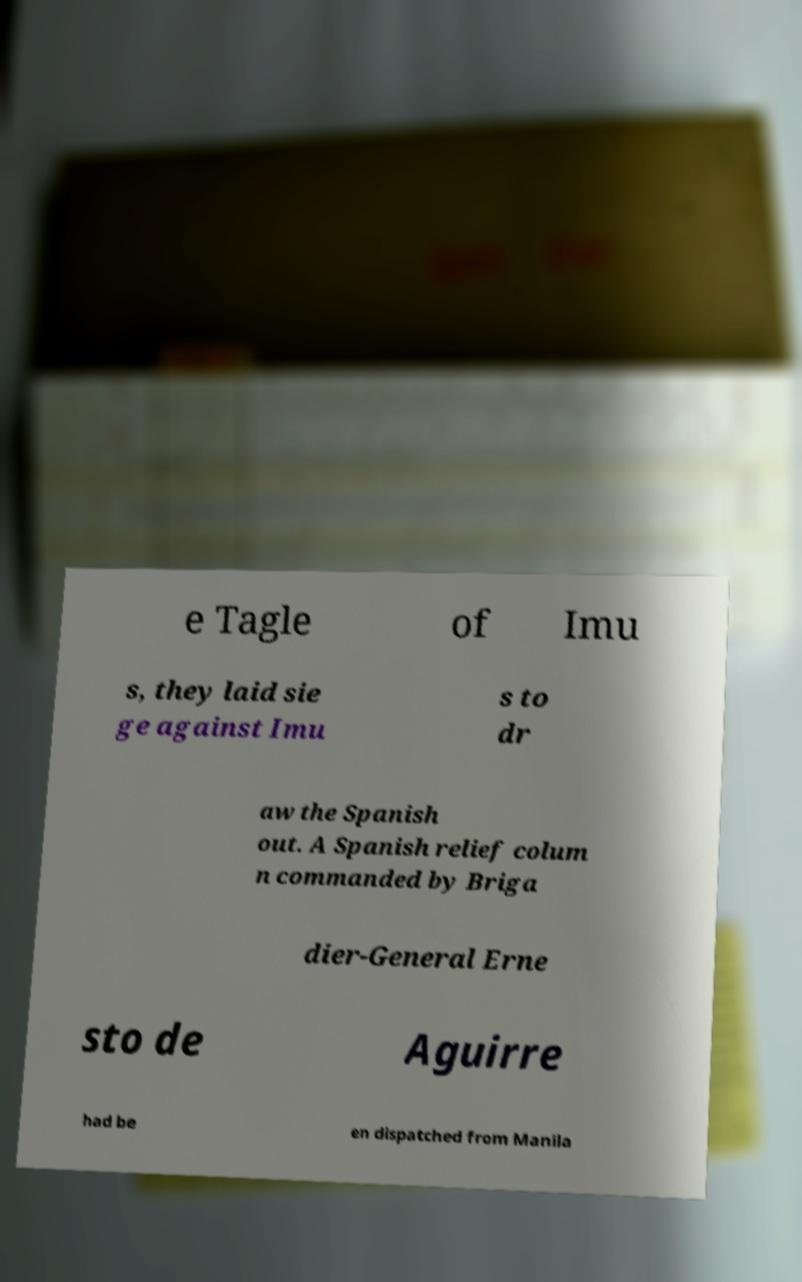I need the written content from this picture converted into text. Can you do that? e Tagle of Imu s, they laid sie ge against Imu s to dr aw the Spanish out. A Spanish relief colum n commanded by Briga dier-General Erne sto de Aguirre had be en dispatched from Manila 